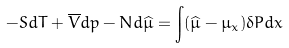<formula> <loc_0><loc_0><loc_500><loc_500>- S d T + \overline { V } d p - N d \widehat { \mu } = \int ( \widehat { \mu } - \mu _ { x } ) \delta P d x</formula> 